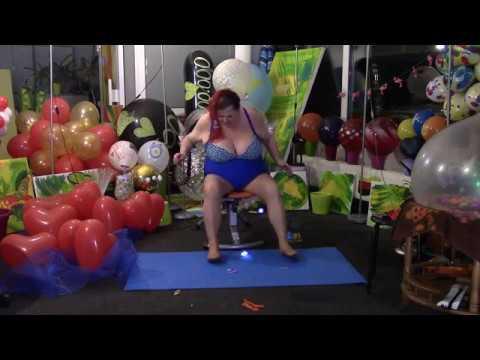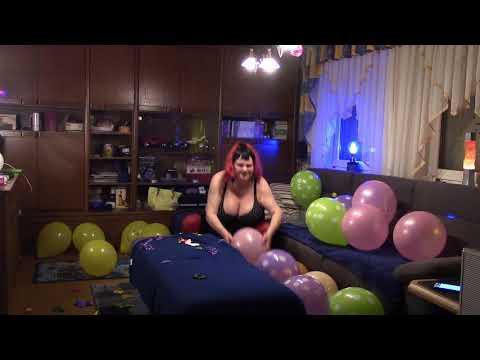The first image is the image on the left, the second image is the image on the right. For the images displayed, is the sentence "In at least one image there is a woman with a pair of high heels above a balloon." factually correct? Answer yes or no. No. The first image is the image on the left, the second image is the image on the right. Evaluate the accuracy of this statement regarding the images: "The right image shows a foot in a stilleto heeled shoe above a green balloon, with various colors of balloons around it on the floor.". Is it true? Answer yes or no. No. 